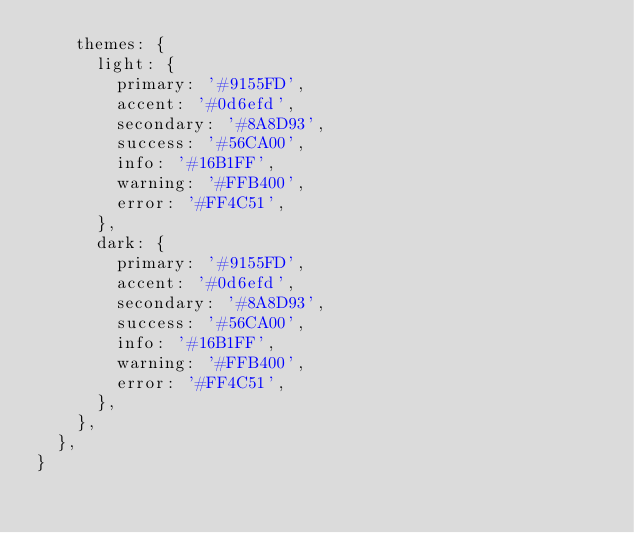<code> <loc_0><loc_0><loc_500><loc_500><_JavaScript_>    themes: {
      light: {
        primary: '#9155FD',
        accent: '#0d6efd',
        secondary: '#8A8D93',
        success: '#56CA00',
        info: '#16B1FF',
        warning: '#FFB400',
        error: '#FF4C51',
      },
      dark: {
        primary: '#9155FD',
        accent: '#0d6efd',
        secondary: '#8A8D93',
        success: '#56CA00',
        info: '#16B1FF',
        warning: '#FFB400',
        error: '#FF4C51',
      },
    },
  },
}
</code> 